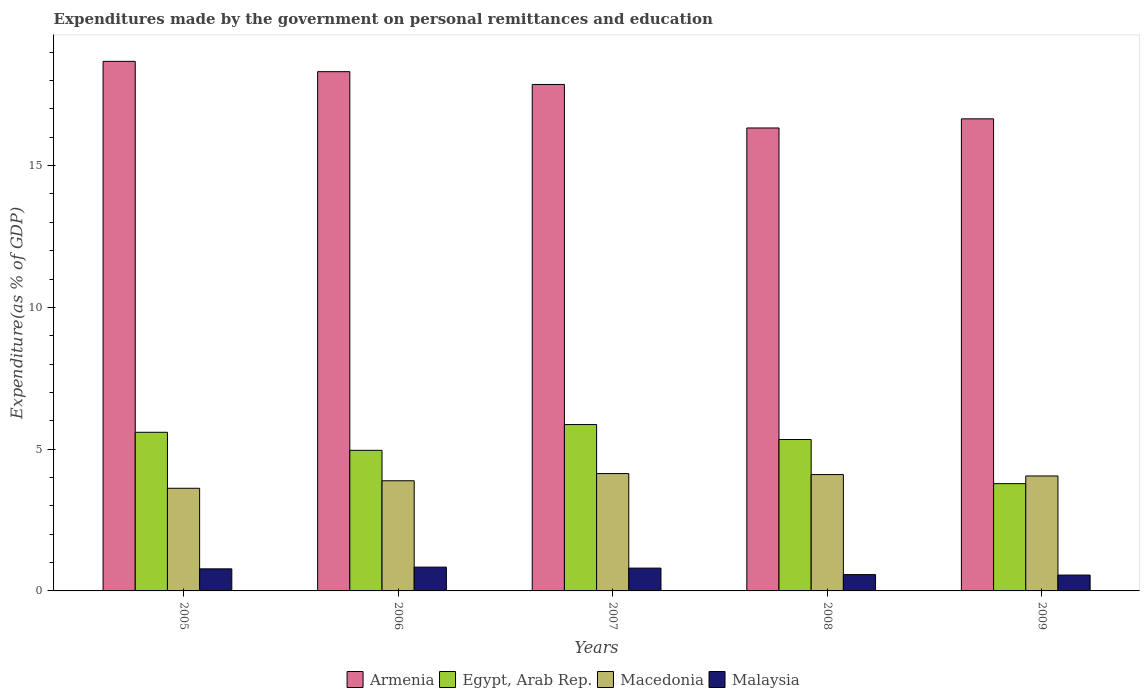Are the number of bars per tick equal to the number of legend labels?
Your answer should be compact. Yes. How many bars are there on the 2nd tick from the left?
Ensure brevity in your answer.  4. How many bars are there on the 5th tick from the right?
Your response must be concise. 4. What is the expenditures made by the government on personal remittances and education in Armenia in 2005?
Offer a very short reply. 18.68. Across all years, what is the maximum expenditures made by the government on personal remittances and education in Macedonia?
Keep it short and to the point. 4.14. Across all years, what is the minimum expenditures made by the government on personal remittances and education in Malaysia?
Your response must be concise. 0.56. In which year was the expenditures made by the government on personal remittances and education in Malaysia maximum?
Make the answer very short. 2006. What is the total expenditures made by the government on personal remittances and education in Armenia in the graph?
Provide a succinct answer. 87.83. What is the difference between the expenditures made by the government on personal remittances and education in Armenia in 2005 and that in 2007?
Ensure brevity in your answer.  0.81. What is the difference between the expenditures made by the government on personal remittances and education in Malaysia in 2007 and the expenditures made by the government on personal remittances and education in Macedonia in 2009?
Keep it short and to the point. -3.25. What is the average expenditures made by the government on personal remittances and education in Malaysia per year?
Provide a succinct answer. 0.71. In the year 2006, what is the difference between the expenditures made by the government on personal remittances and education in Egypt, Arab Rep. and expenditures made by the government on personal remittances and education in Armenia?
Provide a short and direct response. -13.35. In how many years, is the expenditures made by the government on personal remittances and education in Egypt, Arab Rep. greater than 3 %?
Give a very brief answer. 5. What is the ratio of the expenditures made by the government on personal remittances and education in Macedonia in 2005 to that in 2006?
Give a very brief answer. 0.93. Is the expenditures made by the government on personal remittances and education in Armenia in 2006 less than that in 2008?
Ensure brevity in your answer.  No. Is the difference between the expenditures made by the government on personal remittances and education in Egypt, Arab Rep. in 2007 and 2009 greater than the difference between the expenditures made by the government on personal remittances and education in Armenia in 2007 and 2009?
Your answer should be very brief. Yes. What is the difference between the highest and the second highest expenditures made by the government on personal remittances and education in Malaysia?
Offer a terse response. 0.04. What is the difference between the highest and the lowest expenditures made by the government on personal remittances and education in Malaysia?
Provide a short and direct response. 0.28. Is it the case that in every year, the sum of the expenditures made by the government on personal remittances and education in Macedonia and expenditures made by the government on personal remittances and education in Malaysia is greater than the sum of expenditures made by the government on personal remittances and education in Egypt, Arab Rep. and expenditures made by the government on personal remittances and education in Armenia?
Your response must be concise. No. What does the 1st bar from the left in 2006 represents?
Ensure brevity in your answer.  Armenia. What does the 3rd bar from the right in 2005 represents?
Give a very brief answer. Egypt, Arab Rep. What is the difference between two consecutive major ticks on the Y-axis?
Make the answer very short. 5. Does the graph contain any zero values?
Offer a terse response. No. Where does the legend appear in the graph?
Offer a very short reply. Bottom center. How many legend labels are there?
Your answer should be compact. 4. What is the title of the graph?
Offer a very short reply. Expenditures made by the government on personal remittances and education. Does "Central Europe" appear as one of the legend labels in the graph?
Your response must be concise. No. What is the label or title of the X-axis?
Provide a succinct answer. Years. What is the label or title of the Y-axis?
Your answer should be very brief. Expenditure(as % of GDP). What is the Expenditure(as % of GDP) of Armenia in 2005?
Provide a succinct answer. 18.68. What is the Expenditure(as % of GDP) of Egypt, Arab Rep. in 2005?
Your answer should be very brief. 5.59. What is the Expenditure(as % of GDP) of Macedonia in 2005?
Provide a succinct answer. 3.62. What is the Expenditure(as % of GDP) of Malaysia in 2005?
Offer a very short reply. 0.78. What is the Expenditure(as % of GDP) of Armenia in 2006?
Offer a terse response. 18.31. What is the Expenditure(as % of GDP) of Egypt, Arab Rep. in 2006?
Offer a very short reply. 4.96. What is the Expenditure(as % of GDP) of Macedonia in 2006?
Keep it short and to the point. 3.88. What is the Expenditure(as % of GDP) in Malaysia in 2006?
Give a very brief answer. 0.84. What is the Expenditure(as % of GDP) of Armenia in 2007?
Keep it short and to the point. 17.86. What is the Expenditure(as % of GDP) of Egypt, Arab Rep. in 2007?
Ensure brevity in your answer.  5.87. What is the Expenditure(as % of GDP) of Macedonia in 2007?
Offer a very short reply. 4.14. What is the Expenditure(as % of GDP) of Malaysia in 2007?
Keep it short and to the point. 0.8. What is the Expenditure(as % of GDP) in Armenia in 2008?
Your response must be concise. 16.33. What is the Expenditure(as % of GDP) of Egypt, Arab Rep. in 2008?
Your answer should be compact. 5.34. What is the Expenditure(as % of GDP) in Macedonia in 2008?
Give a very brief answer. 4.1. What is the Expenditure(as % of GDP) in Malaysia in 2008?
Ensure brevity in your answer.  0.58. What is the Expenditure(as % of GDP) of Armenia in 2009?
Give a very brief answer. 16.65. What is the Expenditure(as % of GDP) in Egypt, Arab Rep. in 2009?
Ensure brevity in your answer.  3.78. What is the Expenditure(as % of GDP) in Macedonia in 2009?
Ensure brevity in your answer.  4.05. What is the Expenditure(as % of GDP) in Malaysia in 2009?
Your answer should be very brief. 0.56. Across all years, what is the maximum Expenditure(as % of GDP) in Armenia?
Offer a very short reply. 18.68. Across all years, what is the maximum Expenditure(as % of GDP) in Egypt, Arab Rep.?
Your response must be concise. 5.87. Across all years, what is the maximum Expenditure(as % of GDP) of Macedonia?
Offer a terse response. 4.14. Across all years, what is the maximum Expenditure(as % of GDP) of Malaysia?
Keep it short and to the point. 0.84. Across all years, what is the minimum Expenditure(as % of GDP) in Armenia?
Provide a succinct answer. 16.33. Across all years, what is the minimum Expenditure(as % of GDP) of Egypt, Arab Rep.?
Your answer should be compact. 3.78. Across all years, what is the minimum Expenditure(as % of GDP) in Macedonia?
Ensure brevity in your answer.  3.62. Across all years, what is the minimum Expenditure(as % of GDP) in Malaysia?
Your response must be concise. 0.56. What is the total Expenditure(as % of GDP) of Armenia in the graph?
Offer a terse response. 87.83. What is the total Expenditure(as % of GDP) of Egypt, Arab Rep. in the graph?
Make the answer very short. 25.54. What is the total Expenditure(as % of GDP) of Macedonia in the graph?
Give a very brief answer. 19.8. What is the total Expenditure(as % of GDP) of Malaysia in the graph?
Offer a very short reply. 3.56. What is the difference between the Expenditure(as % of GDP) in Armenia in 2005 and that in 2006?
Provide a short and direct response. 0.36. What is the difference between the Expenditure(as % of GDP) in Egypt, Arab Rep. in 2005 and that in 2006?
Keep it short and to the point. 0.64. What is the difference between the Expenditure(as % of GDP) in Macedonia in 2005 and that in 2006?
Provide a short and direct response. -0.26. What is the difference between the Expenditure(as % of GDP) of Malaysia in 2005 and that in 2006?
Give a very brief answer. -0.06. What is the difference between the Expenditure(as % of GDP) in Armenia in 2005 and that in 2007?
Your response must be concise. 0.81. What is the difference between the Expenditure(as % of GDP) in Egypt, Arab Rep. in 2005 and that in 2007?
Your answer should be compact. -0.27. What is the difference between the Expenditure(as % of GDP) in Macedonia in 2005 and that in 2007?
Your response must be concise. -0.52. What is the difference between the Expenditure(as % of GDP) in Malaysia in 2005 and that in 2007?
Your answer should be compact. -0.03. What is the difference between the Expenditure(as % of GDP) in Armenia in 2005 and that in 2008?
Provide a short and direct response. 2.35. What is the difference between the Expenditure(as % of GDP) of Egypt, Arab Rep. in 2005 and that in 2008?
Keep it short and to the point. 0.25. What is the difference between the Expenditure(as % of GDP) in Macedonia in 2005 and that in 2008?
Your answer should be very brief. -0.48. What is the difference between the Expenditure(as % of GDP) in Malaysia in 2005 and that in 2008?
Your answer should be very brief. 0.2. What is the difference between the Expenditure(as % of GDP) of Armenia in 2005 and that in 2009?
Offer a very short reply. 2.03. What is the difference between the Expenditure(as % of GDP) in Egypt, Arab Rep. in 2005 and that in 2009?
Offer a terse response. 1.81. What is the difference between the Expenditure(as % of GDP) of Macedonia in 2005 and that in 2009?
Give a very brief answer. -0.43. What is the difference between the Expenditure(as % of GDP) of Malaysia in 2005 and that in 2009?
Provide a short and direct response. 0.22. What is the difference between the Expenditure(as % of GDP) of Armenia in 2006 and that in 2007?
Give a very brief answer. 0.45. What is the difference between the Expenditure(as % of GDP) of Egypt, Arab Rep. in 2006 and that in 2007?
Your answer should be compact. -0.91. What is the difference between the Expenditure(as % of GDP) of Macedonia in 2006 and that in 2007?
Ensure brevity in your answer.  -0.25. What is the difference between the Expenditure(as % of GDP) of Malaysia in 2006 and that in 2007?
Your response must be concise. 0.04. What is the difference between the Expenditure(as % of GDP) in Armenia in 2006 and that in 2008?
Your answer should be very brief. 1.99. What is the difference between the Expenditure(as % of GDP) in Egypt, Arab Rep. in 2006 and that in 2008?
Offer a terse response. -0.38. What is the difference between the Expenditure(as % of GDP) in Macedonia in 2006 and that in 2008?
Keep it short and to the point. -0.22. What is the difference between the Expenditure(as % of GDP) in Malaysia in 2006 and that in 2008?
Offer a very short reply. 0.26. What is the difference between the Expenditure(as % of GDP) in Armenia in 2006 and that in 2009?
Your answer should be very brief. 1.66. What is the difference between the Expenditure(as % of GDP) in Egypt, Arab Rep. in 2006 and that in 2009?
Your response must be concise. 1.18. What is the difference between the Expenditure(as % of GDP) of Macedonia in 2006 and that in 2009?
Your response must be concise. -0.17. What is the difference between the Expenditure(as % of GDP) of Malaysia in 2006 and that in 2009?
Your answer should be compact. 0.28. What is the difference between the Expenditure(as % of GDP) in Armenia in 2007 and that in 2008?
Keep it short and to the point. 1.53. What is the difference between the Expenditure(as % of GDP) in Egypt, Arab Rep. in 2007 and that in 2008?
Offer a very short reply. 0.53. What is the difference between the Expenditure(as % of GDP) of Macedonia in 2007 and that in 2008?
Offer a terse response. 0.04. What is the difference between the Expenditure(as % of GDP) in Malaysia in 2007 and that in 2008?
Offer a terse response. 0.23. What is the difference between the Expenditure(as % of GDP) in Armenia in 2007 and that in 2009?
Offer a very short reply. 1.21. What is the difference between the Expenditure(as % of GDP) of Egypt, Arab Rep. in 2007 and that in 2009?
Your answer should be very brief. 2.08. What is the difference between the Expenditure(as % of GDP) in Macedonia in 2007 and that in 2009?
Your response must be concise. 0.08. What is the difference between the Expenditure(as % of GDP) of Malaysia in 2007 and that in 2009?
Your answer should be compact. 0.24. What is the difference between the Expenditure(as % of GDP) in Armenia in 2008 and that in 2009?
Ensure brevity in your answer.  -0.32. What is the difference between the Expenditure(as % of GDP) in Egypt, Arab Rep. in 2008 and that in 2009?
Offer a terse response. 1.56. What is the difference between the Expenditure(as % of GDP) in Macedonia in 2008 and that in 2009?
Offer a very short reply. 0.05. What is the difference between the Expenditure(as % of GDP) of Malaysia in 2008 and that in 2009?
Provide a succinct answer. 0.02. What is the difference between the Expenditure(as % of GDP) in Armenia in 2005 and the Expenditure(as % of GDP) in Egypt, Arab Rep. in 2006?
Give a very brief answer. 13.72. What is the difference between the Expenditure(as % of GDP) in Armenia in 2005 and the Expenditure(as % of GDP) in Macedonia in 2006?
Offer a terse response. 14.79. What is the difference between the Expenditure(as % of GDP) in Armenia in 2005 and the Expenditure(as % of GDP) in Malaysia in 2006?
Your answer should be very brief. 17.84. What is the difference between the Expenditure(as % of GDP) of Egypt, Arab Rep. in 2005 and the Expenditure(as % of GDP) of Macedonia in 2006?
Ensure brevity in your answer.  1.71. What is the difference between the Expenditure(as % of GDP) in Egypt, Arab Rep. in 2005 and the Expenditure(as % of GDP) in Malaysia in 2006?
Your response must be concise. 4.75. What is the difference between the Expenditure(as % of GDP) of Macedonia in 2005 and the Expenditure(as % of GDP) of Malaysia in 2006?
Your response must be concise. 2.78. What is the difference between the Expenditure(as % of GDP) in Armenia in 2005 and the Expenditure(as % of GDP) in Egypt, Arab Rep. in 2007?
Keep it short and to the point. 12.81. What is the difference between the Expenditure(as % of GDP) in Armenia in 2005 and the Expenditure(as % of GDP) in Macedonia in 2007?
Your answer should be compact. 14.54. What is the difference between the Expenditure(as % of GDP) of Armenia in 2005 and the Expenditure(as % of GDP) of Malaysia in 2007?
Offer a very short reply. 17.87. What is the difference between the Expenditure(as % of GDP) of Egypt, Arab Rep. in 2005 and the Expenditure(as % of GDP) of Macedonia in 2007?
Keep it short and to the point. 1.46. What is the difference between the Expenditure(as % of GDP) of Egypt, Arab Rep. in 2005 and the Expenditure(as % of GDP) of Malaysia in 2007?
Offer a terse response. 4.79. What is the difference between the Expenditure(as % of GDP) in Macedonia in 2005 and the Expenditure(as % of GDP) in Malaysia in 2007?
Offer a very short reply. 2.82. What is the difference between the Expenditure(as % of GDP) of Armenia in 2005 and the Expenditure(as % of GDP) of Egypt, Arab Rep. in 2008?
Keep it short and to the point. 13.34. What is the difference between the Expenditure(as % of GDP) of Armenia in 2005 and the Expenditure(as % of GDP) of Macedonia in 2008?
Offer a very short reply. 14.57. What is the difference between the Expenditure(as % of GDP) of Armenia in 2005 and the Expenditure(as % of GDP) of Malaysia in 2008?
Your response must be concise. 18.1. What is the difference between the Expenditure(as % of GDP) in Egypt, Arab Rep. in 2005 and the Expenditure(as % of GDP) in Macedonia in 2008?
Your response must be concise. 1.49. What is the difference between the Expenditure(as % of GDP) of Egypt, Arab Rep. in 2005 and the Expenditure(as % of GDP) of Malaysia in 2008?
Offer a very short reply. 5.02. What is the difference between the Expenditure(as % of GDP) in Macedonia in 2005 and the Expenditure(as % of GDP) in Malaysia in 2008?
Your answer should be compact. 3.04. What is the difference between the Expenditure(as % of GDP) of Armenia in 2005 and the Expenditure(as % of GDP) of Egypt, Arab Rep. in 2009?
Offer a terse response. 14.89. What is the difference between the Expenditure(as % of GDP) of Armenia in 2005 and the Expenditure(as % of GDP) of Macedonia in 2009?
Provide a short and direct response. 14.62. What is the difference between the Expenditure(as % of GDP) in Armenia in 2005 and the Expenditure(as % of GDP) in Malaysia in 2009?
Your answer should be very brief. 18.12. What is the difference between the Expenditure(as % of GDP) in Egypt, Arab Rep. in 2005 and the Expenditure(as % of GDP) in Macedonia in 2009?
Offer a terse response. 1.54. What is the difference between the Expenditure(as % of GDP) of Egypt, Arab Rep. in 2005 and the Expenditure(as % of GDP) of Malaysia in 2009?
Offer a very short reply. 5.04. What is the difference between the Expenditure(as % of GDP) of Macedonia in 2005 and the Expenditure(as % of GDP) of Malaysia in 2009?
Offer a very short reply. 3.06. What is the difference between the Expenditure(as % of GDP) of Armenia in 2006 and the Expenditure(as % of GDP) of Egypt, Arab Rep. in 2007?
Make the answer very short. 12.45. What is the difference between the Expenditure(as % of GDP) in Armenia in 2006 and the Expenditure(as % of GDP) in Macedonia in 2007?
Keep it short and to the point. 14.17. What is the difference between the Expenditure(as % of GDP) in Armenia in 2006 and the Expenditure(as % of GDP) in Malaysia in 2007?
Keep it short and to the point. 17.51. What is the difference between the Expenditure(as % of GDP) of Egypt, Arab Rep. in 2006 and the Expenditure(as % of GDP) of Macedonia in 2007?
Your answer should be very brief. 0.82. What is the difference between the Expenditure(as % of GDP) of Egypt, Arab Rep. in 2006 and the Expenditure(as % of GDP) of Malaysia in 2007?
Offer a very short reply. 4.15. What is the difference between the Expenditure(as % of GDP) of Macedonia in 2006 and the Expenditure(as % of GDP) of Malaysia in 2007?
Provide a short and direct response. 3.08. What is the difference between the Expenditure(as % of GDP) of Armenia in 2006 and the Expenditure(as % of GDP) of Egypt, Arab Rep. in 2008?
Give a very brief answer. 12.97. What is the difference between the Expenditure(as % of GDP) in Armenia in 2006 and the Expenditure(as % of GDP) in Macedonia in 2008?
Offer a terse response. 14.21. What is the difference between the Expenditure(as % of GDP) of Armenia in 2006 and the Expenditure(as % of GDP) of Malaysia in 2008?
Your response must be concise. 17.74. What is the difference between the Expenditure(as % of GDP) of Egypt, Arab Rep. in 2006 and the Expenditure(as % of GDP) of Macedonia in 2008?
Offer a very short reply. 0.85. What is the difference between the Expenditure(as % of GDP) of Egypt, Arab Rep. in 2006 and the Expenditure(as % of GDP) of Malaysia in 2008?
Provide a short and direct response. 4.38. What is the difference between the Expenditure(as % of GDP) in Macedonia in 2006 and the Expenditure(as % of GDP) in Malaysia in 2008?
Your response must be concise. 3.31. What is the difference between the Expenditure(as % of GDP) of Armenia in 2006 and the Expenditure(as % of GDP) of Egypt, Arab Rep. in 2009?
Offer a terse response. 14.53. What is the difference between the Expenditure(as % of GDP) in Armenia in 2006 and the Expenditure(as % of GDP) in Macedonia in 2009?
Your answer should be very brief. 14.26. What is the difference between the Expenditure(as % of GDP) of Armenia in 2006 and the Expenditure(as % of GDP) of Malaysia in 2009?
Make the answer very short. 17.75. What is the difference between the Expenditure(as % of GDP) in Egypt, Arab Rep. in 2006 and the Expenditure(as % of GDP) in Macedonia in 2009?
Offer a very short reply. 0.9. What is the difference between the Expenditure(as % of GDP) of Egypt, Arab Rep. in 2006 and the Expenditure(as % of GDP) of Malaysia in 2009?
Keep it short and to the point. 4.4. What is the difference between the Expenditure(as % of GDP) of Macedonia in 2006 and the Expenditure(as % of GDP) of Malaysia in 2009?
Your answer should be very brief. 3.33. What is the difference between the Expenditure(as % of GDP) in Armenia in 2007 and the Expenditure(as % of GDP) in Egypt, Arab Rep. in 2008?
Make the answer very short. 12.52. What is the difference between the Expenditure(as % of GDP) of Armenia in 2007 and the Expenditure(as % of GDP) of Macedonia in 2008?
Offer a terse response. 13.76. What is the difference between the Expenditure(as % of GDP) in Armenia in 2007 and the Expenditure(as % of GDP) in Malaysia in 2008?
Ensure brevity in your answer.  17.29. What is the difference between the Expenditure(as % of GDP) of Egypt, Arab Rep. in 2007 and the Expenditure(as % of GDP) of Macedonia in 2008?
Make the answer very short. 1.76. What is the difference between the Expenditure(as % of GDP) in Egypt, Arab Rep. in 2007 and the Expenditure(as % of GDP) in Malaysia in 2008?
Your response must be concise. 5.29. What is the difference between the Expenditure(as % of GDP) of Macedonia in 2007 and the Expenditure(as % of GDP) of Malaysia in 2008?
Provide a short and direct response. 3.56. What is the difference between the Expenditure(as % of GDP) in Armenia in 2007 and the Expenditure(as % of GDP) in Egypt, Arab Rep. in 2009?
Provide a succinct answer. 14.08. What is the difference between the Expenditure(as % of GDP) in Armenia in 2007 and the Expenditure(as % of GDP) in Macedonia in 2009?
Offer a very short reply. 13.81. What is the difference between the Expenditure(as % of GDP) of Armenia in 2007 and the Expenditure(as % of GDP) of Malaysia in 2009?
Offer a very short reply. 17.3. What is the difference between the Expenditure(as % of GDP) of Egypt, Arab Rep. in 2007 and the Expenditure(as % of GDP) of Macedonia in 2009?
Your answer should be very brief. 1.81. What is the difference between the Expenditure(as % of GDP) in Egypt, Arab Rep. in 2007 and the Expenditure(as % of GDP) in Malaysia in 2009?
Offer a very short reply. 5.31. What is the difference between the Expenditure(as % of GDP) of Macedonia in 2007 and the Expenditure(as % of GDP) of Malaysia in 2009?
Offer a terse response. 3.58. What is the difference between the Expenditure(as % of GDP) of Armenia in 2008 and the Expenditure(as % of GDP) of Egypt, Arab Rep. in 2009?
Ensure brevity in your answer.  12.54. What is the difference between the Expenditure(as % of GDP) in Armenia in 2008 and the Expenditure(as % of GDP) in Macedonia in 2009?
Offer a very short reply. 12.27. What is the difference between the Expenditure(as % of GDP) in Armenia in 2008 and the Expenditure(as % of GDP) in Malaysia in 2009?
Keep it short and to the point. 15.77. What is the difference between the Expenditure(as % of GDP) in Egypt, Arab Rep. in 2008 and the Expenditure(as % of GDP) in Macedonia in 2009?
Provide a succinct answer. 1.29. What is the difference between the Expenditure(as % of GDP) of Egypt, Arab Rep. in 2008 and the Expenditure(as % of GDP) of Malaysia in 2009?
Provide a succinct answer. 4.78. What is the difference between the Expenditure(as % of GDP) of Macedonia in 2008 and the Expenditure(as % of GDP) of Malaysia in 2009?
Offer a terse response. 3.54. What is the average Expenditure(as % of GDP) in Armenia per year?
Your response must be concise. 17.57. What is the average Expenditure(as % of GDP) of Egypt, Arab Rep. per year?
Give a very brief answer. 5.11. What is the average Expenditure(as % of GDP) in Macedonia per year?
Offer a terse response. 3.96. What is the average Expenditure(as % of GDP) of Malaysia per year?
Your response must be concise. 0.71. In the year 2005, what is the difference between the Expenditure(as % of GDP) of Armenia and Expenditure(as % of GDP) of Egypt, Arab Rep.?
Your answer should be compact. 13.08. In the year 2005, what is the difference between the Expenditure(as % of GDP) in Armenia and Expenditure(as % of GDP) in Macedonia?
Ensure brevity in your answer.  15.06. In the year 2005, what is the difference between the Expenditure(as % of GDP) of Armenia and Expenditure(as % of GDP) of Malaysia?
Provide a succinct answer. 17.9. In the year 2005, what is the difference between the Expenditure(as % of GDP) in Egypt, Arab Rep. and Expenditure(as % of GDP) in Macedonia?
Make the answer very short. 1.97. In the year 2005, what is the difference between the Expenditure(as % of GDP) of Egypt, Arab Rep. and Expenditure(as % of GDP) of Malaysia?
Your answer should be compact. 4.82. In the year 2005, what is the difference between the Expenditure(as % of GDP) of Macedonia and Expenditure(as % of GDP) of Malaysia?
Ensure brevity in your answer.  2.84. In the year 2006, what is the difference between the Expenditure(as % of GDP) in Armenia and Expenditure(as % of GDP) in Egypt, Arab Rep.?
Your answer should be compact. 13.35. In the year 2006, what is the difference between the Expenditure(as % of GDP) in Armenia and Expenditure(as % of GDP) in Macedonia?
Keep it short and to the point. 14.43. In the year 2006, what is the difference between the Expenditure(as % of GDP) of Armenia and Expenditure(as % of GDP) of Malaysia?
Make the answer very short. 17.47. In the year 2006, what is the difference between the Expenditure(as % of GDP) in Egypt, Arab Rep. and Expenditure(as % of GDP) in Macedonia?
Ensure brevity in your answer.  1.07. In the year 2006, what is the difference between the Expenditure(as % of GDP) of Egypt, Arab Rep. and Expenditure(as % of GDP) of Malaysia?
Provide a succinct answer. 4.12. In the year 2006, what is the difference between the Expenditure(as % of GDP) in Macedonia and Expenditure(as % of GDP) in Malaysia?
Your response must be concise. 3.05. In the year 2007, what is the difference between the Expenditure(as % of GDP) in Armenia and Expenditure(as % of GDP) in Egypt, Arab Rep.?
Keep it short and to the point. 11.99. In the year 2007, what is the difference between the Expenditure(as % of GDP) in Armenia and Expenditure(as % of GDP) in Macedonia?
Ensure brevity in your answer.  13.72. In the year 2007, what is the difference between the Expenditure(as % of GDP) in Armenia and Expenditure(as % of GDP) in Malaysia?
Ensure brevity in your answer.  17.06. In the year 2007, what is the difference between the Expenditure(as % of GDP) of Egypt, Arab Rep. and Expenditure(as % of GDP) of Macedonia?
Your answer should be compact. 1.73. In the year 2007, what is the difference between the Expenditure(as % of GDP) of Egypt, Arab Rep. and Expenditure(as % of GDP) of Malaysia?
Keep it short and to the point. 5.06. In the year 2007, what is the difference between the Expenditure(as % of GDP) of Macedonia and Expenditure(as % of GDP) of Malaysia?
Make the answer very short. 3.33. In the year 2008, what is the difference between the Expenditure(as % of GDP) in Armenia and Expenditure(as % of GDP) in Egypt, Arab Rep.?
Ensure brevity in your answer.  10.99. In the year 2008, what is the difference between the Expenditure(as % of GDP) in Armenia and Expenditure(as % of GDP) in Macedonia?
Provide a short and direct response. 12.22. In the year 2008, what is the difference between the Expenditure(as % of GDP) in Armenia and Expenditure(as % of GDP) in Malaysia?
Make the answer very short. 15.75. In the year 2008, what is the difference between the Expenditure(as % of GDP) in Egypt, Arab Rep. and Expenditure(as % of GDP) in Macedonia?
Make the answer very short. 1.24. In the year 2008, what is the difference between the Expenditure(as % of GDP) in Egypt, Arab Rep. and Expenditure(as % of GDP) in Malaysia?
Make the answer very short. 4.76. In the year 2008, what is the difference between the Expenditure(as % of GDP) of Macedonia and Expenditure(as % of GDP) of Malaysia?
Provide a short and direct response. 3.53. In the year 2009, what is the difference between the Expenditure(as % of GDP) of Armenia and Expenditure(as % of GDP) of Egypt, Arab Rep.?
Your response must be concise. 12.87. In the year 2009, what is the difference between the Expenditure(as % of GDP) in Armenia and Expenditure(as % of GDP) in Macedonia?
Offer a terse response. 12.6. In the year 2009, what is the difference between the Expenditure(as % of GDP) of Armenia and Expenditure(as % of GDP) of Malaysia?
Ensure brevity in your answer.  16.09. In the year 2009, what is the difference between the Expenditure(as % of GDP) in Egypt, Arab Rep. and Expenditure(as % of GDP) in Macedonia?
Your answer should be compact. -0.27. In the year 2009, what is the difference between the Expenditure(as % of GDP) of Egypt, Arab Rep. and Expenditure(as % of GDP) of Malaysia?
Your answer should be compact. 3.22. In the year 2009, what is the difference between the Expenditure(as % of GDP) in Macedonia and Expenditure(as % of GDP) in Malaysia?
Provide a succinct answer. 3.5. What is the ratio of the Expenditure(as % of GDP) in Armenia in 2005 to that in 2006?
Ensure brevity in your answer.  1.02. What is the ratio of the Expenditure(as % of GDP) of Egypt, Arab Rep. in 2005 to that in 2006?
Keep it short and to the point. 1.13. What is the ratio of the Expenditure(as % of GDP) in Macedonia in 2005 to that in 2006?
Keep it short and to the point. 0.93. What is the ratio of the Expenditure(as % of GDP) in Malaysia in 2005 to that in 2006?
Keep it short and to the point. 0.93. What is the ratio of the Expenditure(as % of GDP) in Armenia in 2005 to that in 2007?
Your answer should be compact. 1.05. What is the ratio of the Expenditure(as % of GDP) of Egypt, Arab Rep. in 2005 to that in 2007?
Make the answer very short. 0.95. What is the ratio of the Expenditure(as % of GDP) of Macedonia in 2005 to that in 2007?
Make the answer very short. 0.87. What is the ratio of the Expenditure(as % of GDP) of Malaysia in 2005 to that in 2007?
Your answer should be very brief. 0.97. What is the ratio of the Expenditure(as % of GDP) in Armenia in 2005 to that in 2008?
Your answer should be compact. 1.14. What is the ratio of the Expenditure(as % of GDP) of Egypt, Arab Rep. in 2005 to that in 2008?
Keep it short and to the point. 1.05. What is the ratio of the Expenditure(as % of GDP) of Macedonia in 2005 to that in 2008?
Give a very brief answer. 0.88. What is the ratio of the Expenditure(as % of GDP) of Malaysia in 2005 to that in 2008?
Provide a succinct answer. 1.35. What is the ratio of the Expenditure(as % of GDP) in Armenia in 2005 to that in 2009?
Give a very brief answer. 1.12. What is the ratio of the Expenditure(as % of GDP) of Egypt, Arab Rep. in 2005 to that in 2009?
Provide a short and direct response. 1.48. What is the ratio of the Expenditure(as % of GDP) in Macedonia in 2005 to that in 2009?
Your answer should be very brief. 0.89. What is the ratio of the Expenditure(as % of GDP) of Malaysia in 2005 to that in 2009?
Ensure brevity in your answer.  1.39. What is the ratio of the Expenditure(as % of GDP) of Armenia in 2006 to that in 2007?
Offer a very short reply. 1.03. What is the ratio of the Expenditure(as % of GDP) of Egypt, Arab Rep. in 2006 to that in 2007?
Your answer should be compact. 0.85. What is the ratio of the Expenditure(as % of GDP) of Macedonia in 2006 to that in 2007?
Provide a short and direct response. 0.94. What is the ratio of the Expenditure(as % of GDP) in Malaysia in 2006 to that in 2007?
Your answer should be very brief. 1.04. What is the ratio of the Expenditure(as % of GDP) of Armenia in 2006 to that in 2008?
Offer a terse response. 1.12. What is the ratio of the Expenditure(as % of GDP) of Egypt, Arab Rep. in 2006 to that in 2008?
Offer a very short reply. 0.93. What is the ratio of the Expenditure(as % of GDP) of Macedonia in 2006 to that in 2008?
Your answer should be very brief. 0.95. What is the ratio of the Expenditure(as % of GDP) of Malaysia in 2006 to that in 2008?
Provide a short and direct response. 1.46. What is the ratio of the Expenditure(as % of GDP) in Armenia in 2006 to that in 2009?
Keep it short and to the point. 1.1. What is the ratio of the Expenditure(as % of GDP) in Egypt, Arab Rep. in 2006 to that in 2009?
Your answer should be very brief. 1.31. What is the ratio of the Expenditure(as % of GDP) of Macedonia in 2006 to that in 2009?
Offer a terse response. 0.96. What is the ratio of the Expenditure(as % of GDP) of Malaysia in 2006 to that in 2009?
Offer a terse response. 1.5. What is the ratio of the Expenditure(as % of GDP) of Armenia in 2007 to that in 2008?
Your answer should be compact. 1.09. What is the ratio of the Expenditure(as % of GDP) of Egypt, Arab Rep. in 2007 to that in 2008?
Your answer should be compact. 1.1. What is the ratio of the Expenditure(as % of GDP) in Macedonia in 2007 to that in 2008?
Offer a very short reply. 1.01. What is the ratio of the Expenditure(as % of GDP) in Malaysia in 2007 to that in 2008?
Offer a terse response. 1.4. What is the ratio of the Expenditure(as % of GDP) of Armenia in 2007 to that in 2009?
Your answer should be very brief. 1.07. What is the ratio of the Expenditure(as % of GDP) of Egypt, Arab Rep. in 2007 to that in 2009?
Your answer should be compact. 1.55. What is the ratio of the Expenditure(as % of GDP) in Macedonia in 2007 to that in 2009?
Offer a very short reply. 1.02. What is the ratio of the Expenditure(as % of GDP) of Malaysia in 2007 to that in 2009?
Give a very brief answer. 1.44. What is the ratio of the Expenditure(as % of GDP) of Armenia in 2008 to that in 2009?
Your answer should be compact. 0.98. What is the ratio of the Expenditure(as % of GDP) in Egypt, Arab Rep. in 2008 to that in 2009?
Your response must be concise. 1.41. What is the ratio of the Expenditure(as % of GDP) in Macedonia in 2008 to that in 2009?
Your response must be concise. 1.01. What is the ratio of the Expenditure(as % of GDP) in Malaysia in 2008 to that in 2009?
Give a very brief answer. 1.03. What is the difference between the highest and the second highest Expenditure(as % of GDP) of Armenia?
Offer a very short reply. 0.36. What is the difference between the highest and the second highest Expenditure(as % of GDP) in Egypt, Arab Rep.?
Your answer should be very brief. 0.27. What is the difference between the highest and the second highest Expenditure(as % of GDP) in Macedonia?
Ensure brevity in your answer.  0.04. What is the difference between the highest and the second highest Expenditure(as % of GDP) in Malaysia?
Ensure brevity in your answer.  0.04. What is the difference between the highest and the lowest Expenditure(as % of GDP) of Armenia?
Keep it short and to the point. 2.35. What is the difference between the highest and the lowest Expenditure(as % of GDP) in Egypt, Arab Rep.?
Give a very brief answer. 2.08. What is the difference between the highest and the lowest Expenditure(as % of GDP) of Macedonia?
Make the answer very short. 0.52. What is the difference between the highest and the lowest Expenditure(as % of GDP) in Malaysia?
Offer a very short reply. 0.28. 